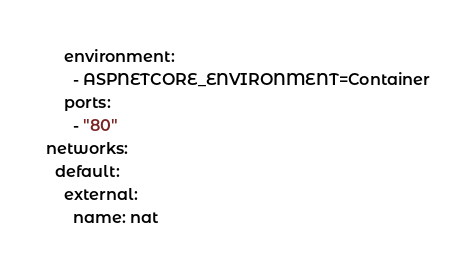Convert code to text. <code><loc_0><loc_0><loc_500><loc_500><_YAML_>    environment:
      - ASPNETCORE_ENVIRONMENT=Container
    ports:
      - "80"
networks:
  default:
    external:
      name: nat

</code> 